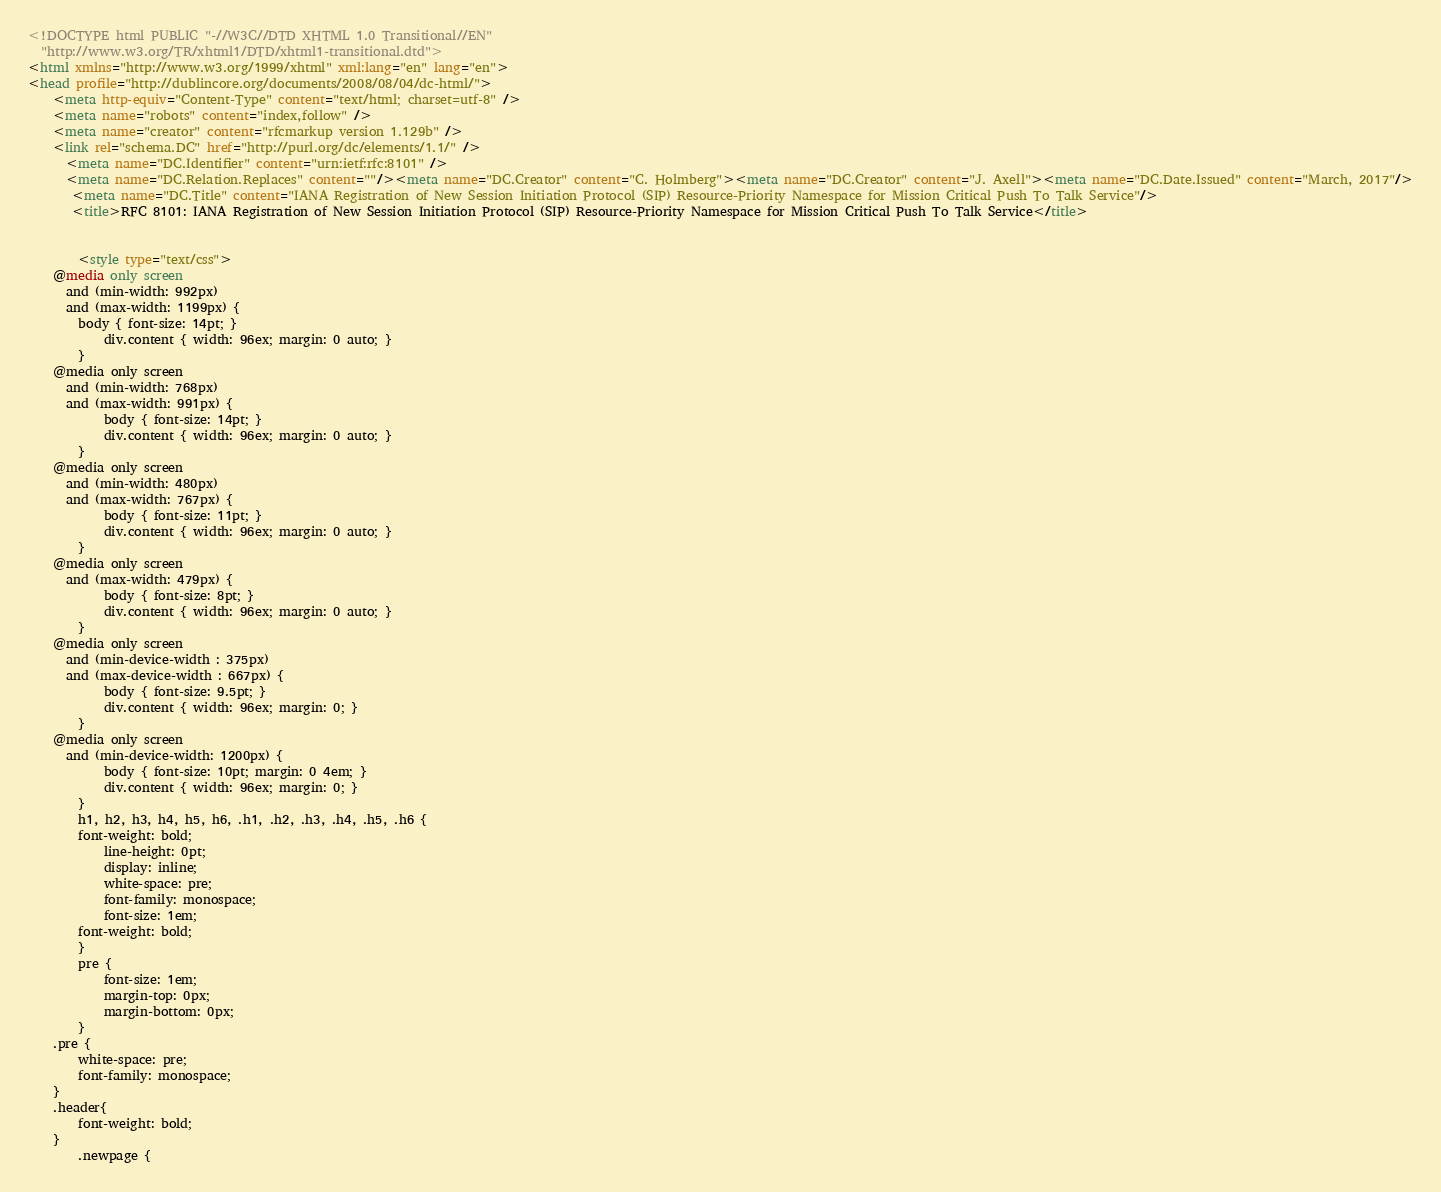Convert code to text. <code><loc_0><loc_0><loc_500><loc_500><_HTML_><!DOCTYPE html PUBLIC "-//W3C//DTD XHTML 1.0 Transitional//EN"
  "http://www.w3.org/TR/xhtml1/DTD/xhtml1-transitional.dtd">
<html xmlns="http://www.w3.org/1999/xhtml" xml:lang="en" lang="en">
<head profile="http://dublincore.org/documents/2008/08/04/dc-html/">
    <meta http-equiv="Content-Type" content="text/html; charset=utf-8" />
    <meta name="robots" content="index,follow" />
    <meta name="creator" content="rfcmarkup version 1.129b" />
    <link rel="schema.DC" href="http://purl.org/dc/elements/1.1/" />
      <meta name="DC.Identifier" content="urn:ietf:rfc:8101" />
      <meta name="DC.Relation.Replaces" content=""/><meta name="DC.Creator" content="C. Holmberg"><meta name="DC.Creator" content="J. Axell"><meta name="DC.Date.Issued" content="March, 2017"/>
       <meta name="DC.Title" content="IANA Registration of New Session Initiation Protocol (SIP) Resource-Priority Namespace for Mission Critical Push To Talk Service"/>
       <title>RFC 8101: IANA Registration of New Session Initiation Protocol (SIP) Resource-Priority Namespace for Mission Critical Push To Talk Service</title>    
        

        <style type="text/css">
	@media only screen 
	  and (min-width: 992px)
	  and (max-width: 1199px) {
	    body { font-size: 14pt; }
            div.content { width: 96ex; margin: 0 auto; }
        }
	@media only screen 
	  and (min-width: 768px)
	  and (max-width: 991px) {
            body { font-size: 14pt; }
            div.content { width: 96ex; margin: 0 auto; }
        }
	@media only screen 
	  and (min-width: 480px)
	  and (max-width: 767px) {
            body { font-size: 11pt; }
            div.content { width: 96ex; margin: 0 auto; }
        }
	@media only screen 
	  and (max-width: 479px) {
            body { font-size: 8pt; }
            div.content { width: 96ex; margin: 0 auto; }
        }
	@media only screen 
	  and (min-device-width : 375px) 
	  and (max-device-width : 667px) {
            body { font-size: 9.5pt; }
            div.content { width: 96ex; margin: 0; }
        }
	@media only screen 
	  and (min-device-width: 1200px) {
            body { font-size: 10pt; margin: 0 4em; }
            div.content { width: 96ex; margin: 0; }
        }
        h1, h2, h3, h4, h5, h6, .h1, .h2, .h3, .h4, .h5, .h6 {
	    font-weight: bold;
            line-height: 0pt;
            display: inline;
            white-space: pre;
            font-family: monospace;
            font-size: 1em;
	    font-weight: bold;
        }
        pre {
            font-size: 1em;
            margin-top: 0px;
            margin-bottom: 0px;
        }
	.pre {
	    white-space: pre;
	    font-family: monospace;
	}
	.header{
	    font-weight: bold;
	}
        .newpage {</code> 